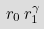Convert formula to latex. <formula><loc_0><loc_0><loc_500><loc_500>r _ { 0 } \, r _ { 1 } ^ { \gamma }</formula> 